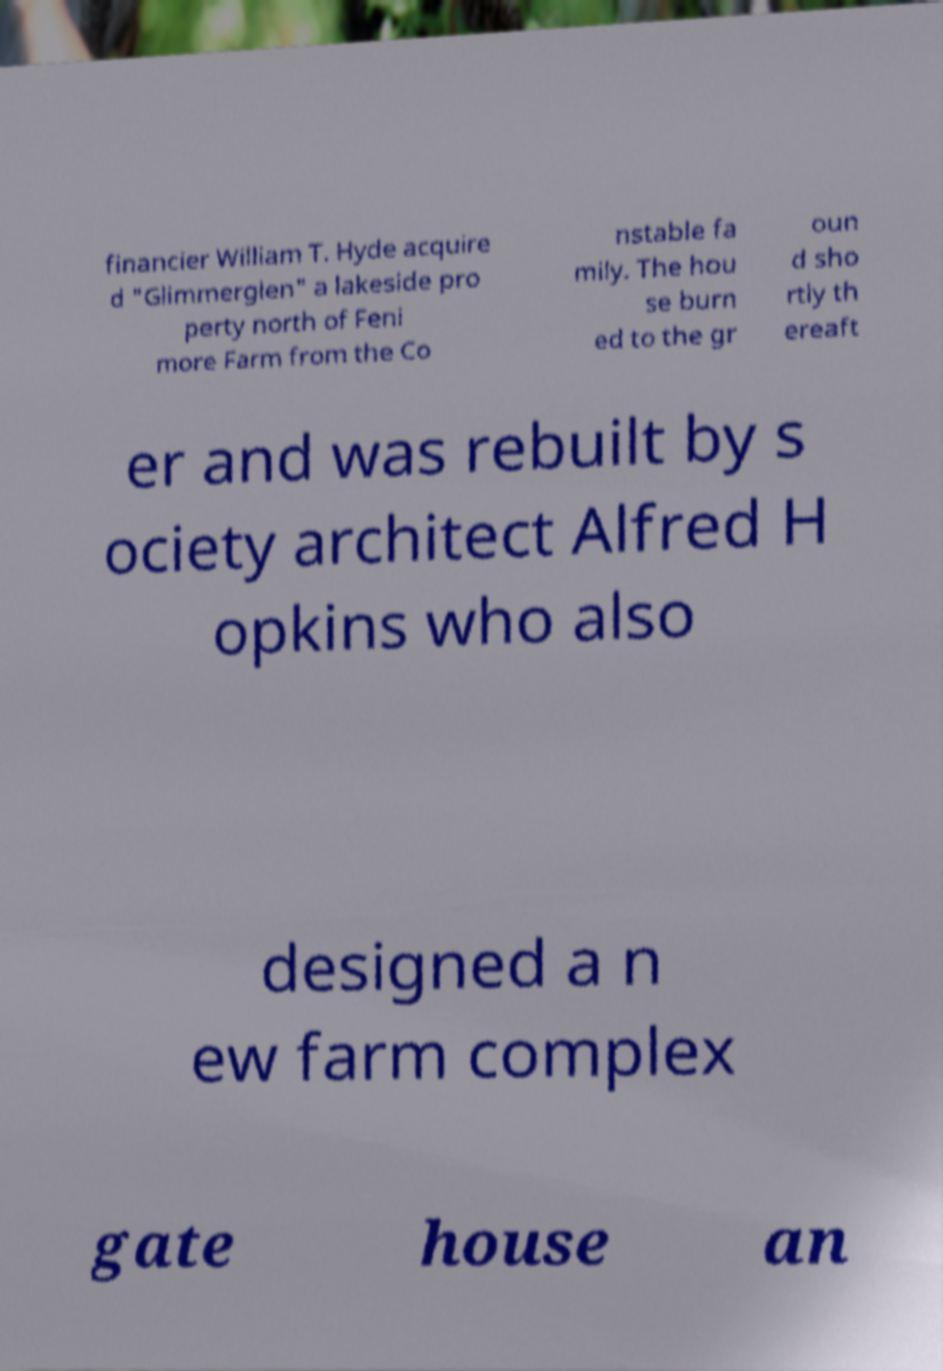Please identify and transcribe the text found in this image. financier William T. Hyde acquire d "Glimmerglen" a lakeside pro perty north of Feni more Farm from the Co nstable fa mily. The hou se burn ed to the gr oun d sho rtly th ereaft er and was rebuilt by s ociety architect Alfred H opkins who also designed a n ew farm complex gate house an 